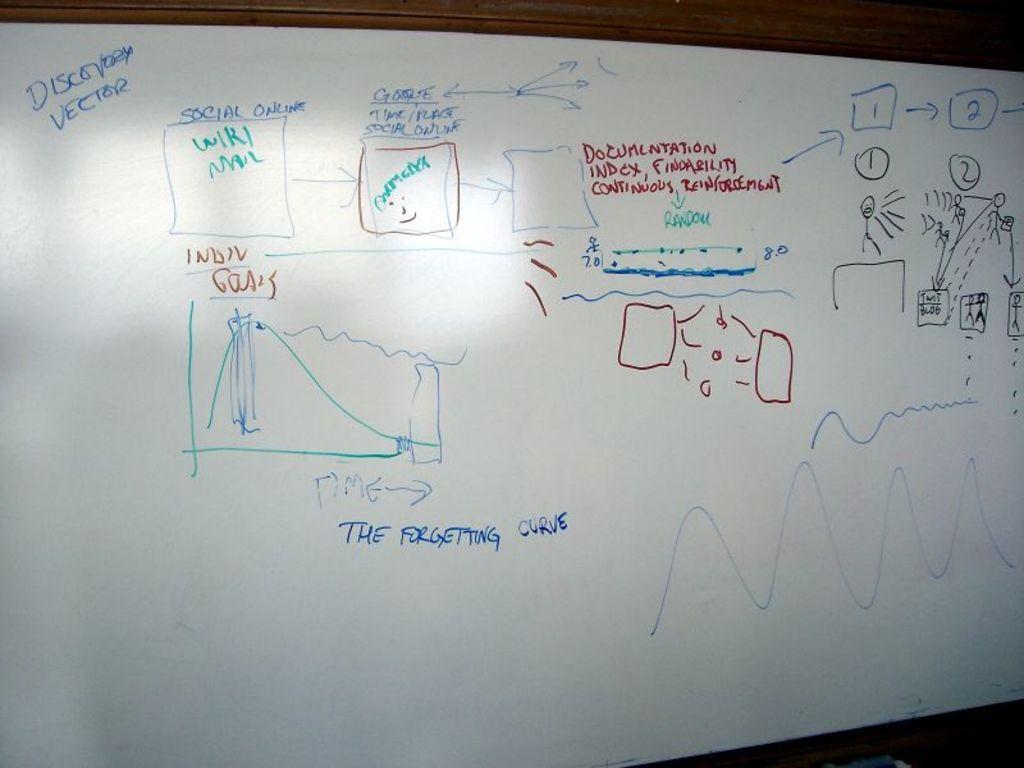In one or two sentences, can you explain what this image depicts? In the center of the image there is a wooden wall. On the wall, we can see one white board. On the board, we can see some numbers and some text. At the bottom right side of the image, we can see some object. 